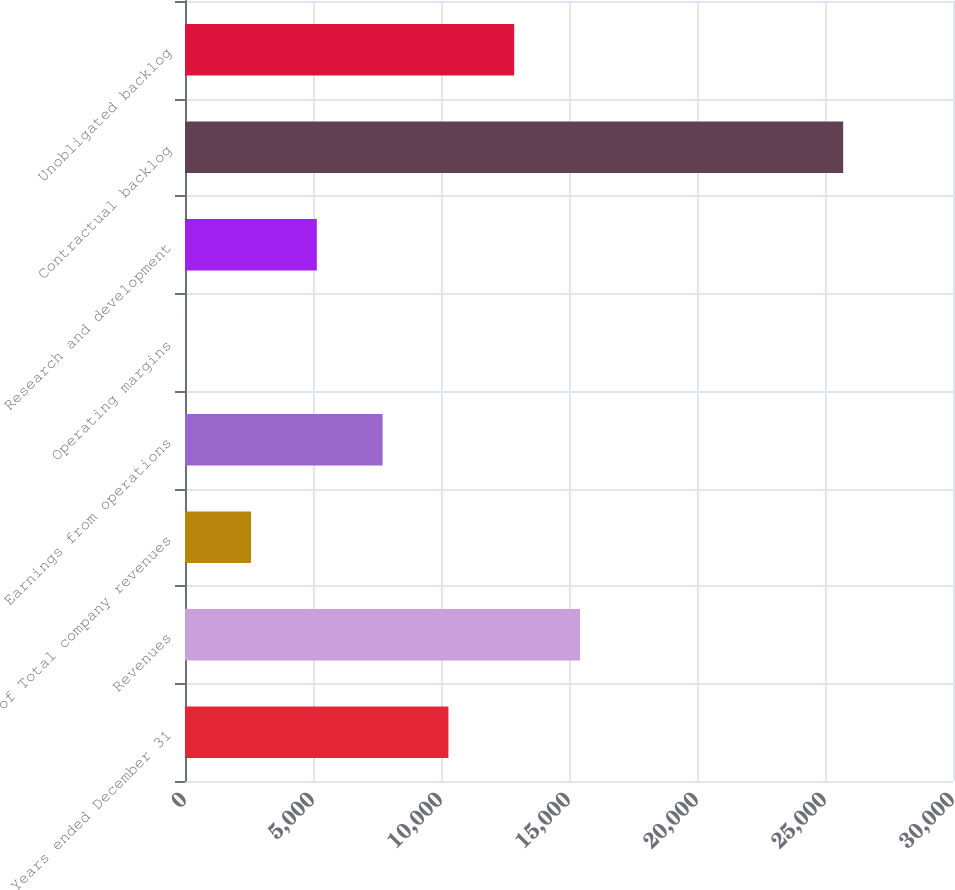Convert chart. <chart><loc_0><loc_0><loc_500><loc_500><bar_chart><fcel>Years ended December 31<fcel>Revenues<fcel>of Total company revenues<fcel>Earnings from operations<fcel>Operating margins<fcel>Research and development<fcel>Contractual backlog<fcel>Unobligated backlog<nl><fcel>10289.8<fcel>15429.8<fcel>2579.64<fcel>7719.72<fcel>9.6<fcel>5149.68<fcel>25710<fcel>12859.8<nl></chart> 